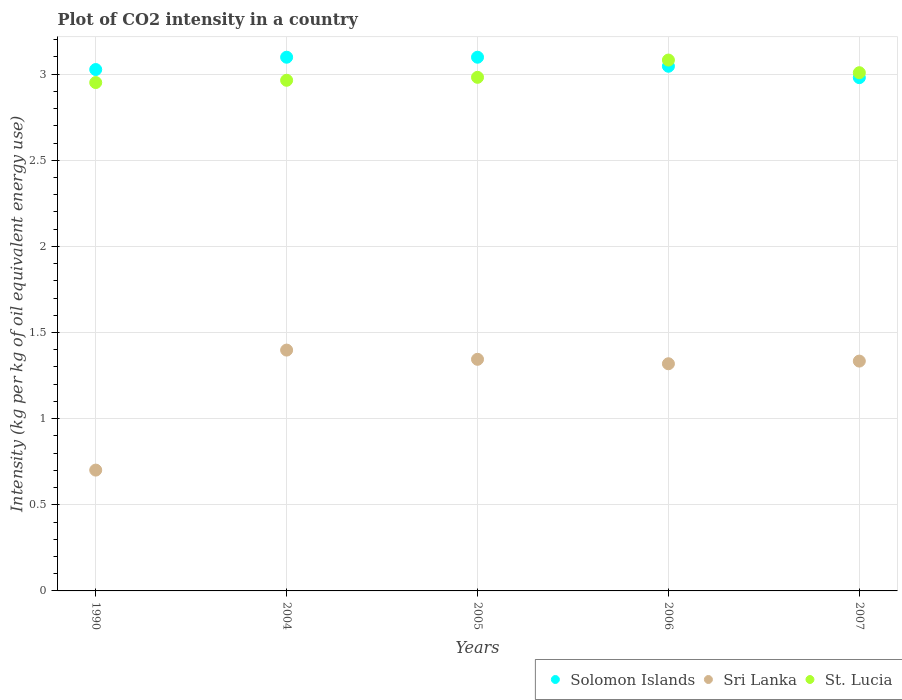What is the CO2 intensity in in Sri Lanka in 2004?
Your answer should be very brief. 1.4. Across all years, what is the maximum CO2 intensity in in St. Lucia?
Your answer should be compact. 3.08. Across all years, what is the minimum CO2 intensity in in St. Lucia?
Your answer should be compact. 2.95. In which year was the CO2 intensity in in St. Lucia maximum?
Provide a succinct answer. 2006. What is the total CO2 intensity in in St. Lucia in the graph?
Offer a very short reply. 14.99. What is the difference between the CO2 intensity in in St. Lucia in 2006 and that in 2007?
Give a very brief answer. 0.07. What is the difference between the CO2 intensity in in Solomon Islands in 2004 and the CO2 intensity in in St. Lucia in 2007?
Offer a very short reply. 0.09. What is the average CO2 intensity in in St. Lucia per year?
Ensure brevity in your answer.  3. In the year 2007, what is the difference between the CO2 intensity in in Sri Lanka and CO2 intensity in in St. Lucia?
Give a very brief answer. -1.67. In how many years, is the CO2 intensity in in St. Lucia greater than 2.2 kg?
Make the answer very short. 5. What is the ratio of the CO2 intensity in in St. Lucia in 1990 to that in 2007?
Give a very brief answer. 0.98. Is the difference between the CO2 intensity in in Sri Lanka in 2004 and 2005 greater than the difference between the CO2 intensity in in St. Lucia in 2004 and 2005?
Your answer should be compact. Yes. What is the difference between the highest and the lowest CO2 intensity in in Sri Lanka?
Keep it short and to the point. 0.7. In how many years, is the CO2 intensity in in Sri Lanka greater than the average CO2 intensity in in Sri Lanka taken over all years?
Keep it short and to the point. 4. Is it the case that in every year, the sum of the CO2 intensity in in St. Lucia and CO2 intensity in in Solomon Islands  is greater than the CO2 intensity in in Sri Lanka?
Provide a succinct answer. Yes. Does the CO2 intensity in in Solomon Islands monotonically increase over the years?
Offer a very short reply. No. Is the CO2 intensity in in St. Lucia strictly less than the CO2 intensity in in Sri Lanka over the years?
Offer a very short reply. No. How are the legend labels stacked?
Make the answer very short. Horizontal. What is the title of the graph?
Ensure brevity in your answer.  Plot of CO2 intensity in a country. What is the label or title of the X-axis?
Offer a very short reply. Years. What is the label or title of the Y-axis?
Your answer should be compact. Intensity (kg per kg of oil equivalent energy use). What is the Intensity (kg per kg of oil equivalent energy use) of Solomon Islands in 1990?
Provide a short and direct response. 3.03. What is the Intensity (kg per kg of oil equivalent energy use) in Sri Lanka in 1990?
Your answer should be compact. 0.7. What is the Intensity (kg per kg of oil equivalent energy use) in St. Lucia in 1990?
Your answer should be compact. 2.95. What is the Intensity (kg per kg of oil equivalent energy use) of Solomon Islands in 2004?
Offer a very short reply. 3.1. What is the Intensity (kg per kg of oil equivalent energy use) of Sri Lanka in 2004?
Offer a very short reply. 1.4. What is the Intensity (kg per kg of oil equivalent energy use) of St. Lucia in 2004?
Your answer should be compact. 2.96. What is the Intensity (kg per kg of oil equivalent energy use) in Solomon Islands in 2005?
Your response must be concise. 3.1. What is the Intensity (kg per kg of oil equivalent energy use) of Sri Lanka in 2005?
Provide a succinct answer. 1.34. What is the Intensity (kg per kg of oil equivalent energy use) of St. Lucia in 2005?
Offer a terse response. 2.98. What is the Intensity (kg per kg of oil equivalent energy use) in Solomon Islands in 2006?
Keep it short and to the point. 3.05. What is the Intensity (kg per kg of oil equivalent energy use) in Sri Lanka in 2006?
Your response must be concise. 1.32. What is the Intensity (kg per kg of oil equivalent energy use) of St. Lucia in 2006?
Keep it short and to the point. 3.08. What is the Intensity (kg per kg of oil equivalent energy use) in Solomon Islands in 2007?
Give a very brief answer. 2.98. What is the Intensity (kg per kg of oil equivalent energy use) of Sri Lanka in 2007?
Your answer should be very brief. 1.33. What is the Intensity (kg per kg of oil equivalent energy use) in St. Lucia in 2007?
Offer a terse response. 3.01. Across all years, what is the maximum Intensity (kg per kg of oil equivalent energy use) in Solomon Islands?
Keep it short and to the point. 3.1. Across all years, what is the maximum Intensity (kg per kg of oil equivalent energy use) of Sri Lanka?
Provide a succinct answer. 1.4. Across all years, what is the maximum Intensity (kg per kg of oil equivalent energy use) of St. Lucia?
Offer a very short reply. 3.08. Across all years, what is the minimum Intensity (kg per kg of oil equivalent energy use) of Solomon Islands?
Give a very brief answer. 2.98. Across all years, what is the minimum Intensity (kg per kg of oil equivalent energy use) in Sri Lanka?
Offer a terse response. 0.7. Across all years, what is the minimum Intensity (kg per kg of oil equivalent energy use) of St. Lucia?
Your answer should be very brief. 2.95. What is the total Intensity (kg per kg of oil equivalent energy use) in Solomon Islands in the graph?
Offer a very short reply. 15.25. What is the total Intensity (kg per kg of oil equivalent energy use) in Sri Lanka in the graph?
Offer a very short reply. 6.1. What is the total Intensity (kg per kg of oil equivalent energy use) of St. Lucia in the graph?
Your answer should be very brief. 14.99. What is the difference between the Intensity (kg per kg of oil equivalent energy use) in Solomon Islands in 1990 and that in 2004?
Provide a short and direct response. -0.07. What is the difference between the Intensity (kg per kg of oil equivalent energy use) in Sri Lanka in 1990 and that in 2004?
Offer a terse response. -0.7. What is the difference between the Intensity (kg per kg of oil equivalent energy use) of St. Lucia in 1990 and that in 2004?
Offer a terse response. -0.01. What is the difference between the Intensity (kg per kg of oil equivalent energy use) in Solomon Islands in 1990 and that in 2005?
Your response must be concise. -0.07. What is the difference between the Intensity (kg per kg of oil equivalent energy use) of Sri Lanka in 1990 and that in 2005?
Offer a very short reply. -0.64. What is the difference between the Intensity (kg per kg of oil equivalent energy use) of St. Lucia in 1990 and that in 2005?
Your response must be concise. -0.03. What is the difference between the Intensity (kg per kg of oil equivalent energy use) of Solomon Islands in 1990 and that in 2006?
Your answer should be very brief. -0.02. What is the difference between the Intensity (kg per kg of oil equivalent energy use) of Sri Lanka in 1990 and that in 2006?
Offer a very short reply. -0.62. What is the difference between the Intensity (kg per kg of oil equivalent energy use) of St. Lucia in 1990 and that in 2006?
Offer a very short reply. -0.13. What is the difference between the Intensity (kg per kg of oil equivalent energy use) of Solomon Islands in 1990 and that in 2007?
Your answer should be very brief. 0.05. What is the difference between the Intensity (kg per kg of oil equivalent energy use) of Sri Lanka in 1990 and that in 2007?
Offer a very short reply. -0.63. What is the difference between the Intensity (kg per kg of oil equivalent energy use) in St. Lucia in 1990 and that in 2007?
Offer a very short reply. -0.06. What is the difference between the Intensity (kg per kg of oil equivalent energy use) of Solomon Islands in 2004 and that in 2005?
Ensure brevity in your answer.  0. What is the difference between the Intensity (kg per kg of oil equivalent energy use) of Sri Lanka in 2004 and that in 2005?
Ensure brevity in your answer.  0.05. What is the difference between the Intensity (kg per kg of oil equivalent energy use) in St. Lucia in 2004 and that in 2005?
Give a very brief answer. -0.02. What is the difference between the Intensity (kg per kg of oil equivalent energy use) in Solomon Islands in 2004 and that in 2006?
Provide a succinct answer. 0.05. What is the difference between the Intensity (kg per kg of oil equivalent energy use) in Sri Lanka in 2004 and that in 2006?
Keep it short and to the point. 0.08. What is the difference between the Intensity (kg per kg of oil equivalent energy use) of St. Lucia in 2004 and that in 2006?
Give a very brief answer. -0.12. What is the difference between the Intensity (kg per kg of oil equivalent energy use) in Solomon Islands in 2004 and that in 2007?
Your answer should be very brief. 0.12. What is the difference between the Intensity (kg per kg of oil equivalent energy use) in Sri Lanka in 2004 and that in 2007?
Offer a very short reply. 0.06. What is the difference between the Intensity (kg per kg of oil equivalent energy use) in St. Lucia in 2004 and that in 2007?
Offer a very short reply. -0.04. What is the difference between the Intensity (kg per kg of oil equivalent energy use) in Solomon Islands in 2005 and that in 2006?
Provide a succinct answer. 0.05. What is the difference between the Intensity (kg per kg of oil equivalent energy use) of Sri Lanka in 2005 and that in 2006?
Make the answer very short. 0.03. What is the difference between the Intensity (kg per kg of oil equivalent energy use) of St. Lucia in 2005 and that in 2006?
Give a very brief answer. -0.1. What is the difference between the Intensity (kg per kg of oil equivalent energy use) of Solomon Islands in 2005 and that in 2007?
Ensure brevity in your answer.  0.12. What is the difference between the Intensity (kg per kg of oil equivalent energy use) of Sri Lanka in 2005 and that in 2007?
Provide a succinct answer. 0.01. What is the difference between the Intensity (kg per kg of oil equivalent energy use) of St. Lucia in 2005 and that in 2007?
Your answer should be very brief. -0.03. What is the difference between the Intensity (kg per kg of oil equivalent energy use) in Solomon Islands in 2006 and that in 2007?
Offer a very short reply. 0.07. What is the difference between the Intensity (kg per kg of oil equivalent energy use) of Sri Lanka in 2006 and that in 2007?
Make the answer very short. -0.02. What is the difference between the Intensity (kg per kg of oil equivalent energy use) in St. Lucia in 2006 and that in 2007?
Provide a short and direct response. 0.07. What is the difference between the Intensity (kg per kg of oil equivalent energy use) in Solomon Islands in 1990 and the Intensity (kg per kg of oil equivalent energy use) in Sri Lanka in 2004?
Make the answer very short. 1.63. What is the difference between the Intensity (kg per kg of oil equivalent energy use) of Solomon Islands in 1990 and the Intensity (kg per kg of oil equivalent energy use) of St. Lucia in 2004?
Make the answer very short. 0.06. What is the difference between the Intensity (kg per kg of oil equivalent energy use) in Sri Lanka in 1990 and the Intensity (kg per kg of oil equivalent energy use) in St. Lucia in 2004?
Offer a terse response. -2.26. What is the difference between the Intensity (kg per kg of oil equivalent energy use) in Solomon Islands in 1990 and the Intensity (kg per kg of oil equivalent energy use) in Sri Lanka in 2005?
Offer a terse response. 1.68. What is the difference between the Intensity (kg per kg of oil equivalent energy use) of Solomon Islands in 1990 and the Intensity (kg per kg of oil equivalent energy use) of St. Lucia in 2005?
Ensure brevity in your answer.  0.05. What is the difference between the Intensity (kg per kg of oil equivalent energy use) of Sri Lanka in 1990 and the Intensity (kg per kg of oil equivalent energy use) of St. Lucia in 2005?
Ensure brevity in your answer.  -2.28. What is the difference between the Intensity (kg per kg of oil equivalent energy use) in Solomon Islands in 1990 and the Intensity (kg per kg of oil equivalent energy use) in Sri Lanka in 2006?
Your response must be concise. 1.71. What is the difference between the Intensity (kg per kg of oil equivalent energy use) in Solomon Islands in 1990 and the Intensity (kg per kg of oil equivalent energy use) in St. Lucia in 2006?
Give a very brief answer. -0.06. What is the difference between the Intensity (kg per kg of oil equivalent energy use) of Sri Lanka in 1990 and the Intensity (kg per kg of oil equivalent energy use) of St. Lucia in 2006?
Offer a very short reply. -2.38. What is the difference between the Intensity (kg per kg of oil equivalent energy use) in Solomon Islands in 1990 and the Intensity (kg per kg of oil equivalent energy use) in Sri Lanka in 2007?
Your answer should be very brief. 1.69. What is the difference between the Intensity (kg per kg of oil equivalent energy use) of Solomon Islands in 1990 and the Intensity (kg per kg of oil equivalent energy use) of St. Lucia in 2007?
Your answer should be compact. 0.02. What is the difference between the Intensity (kg per kg of oil equivalent energy use) in Sri Lanka in 1990 and the Intensity (kg per kg of oil equivalent energy use) in St. Lucia in 2007?
Offer a terse response. -2.31. What is the difference between the Intensity (kg per kg of oil equivalent energy use) of Solomon Islands in 2004 and the Intensity (kg per kg of oil equivalent energy use) of Sri Lanka in 2005?
Make the answer very short. 1.75. What is the difference between the Intensity (kg per kg of oil equivalent energy use) of Solomon Islands in 2004 and the Intensity (kg per kg of oil equivalent energy use) of St. Lucia in 2005?
Your answer should be compact. 0.12. What is the difference between the Intensity (kg per kg of oil equivalent energy use) in Sri Lanka in 2004 and the Intensity (kg per kg of oil equivalent energy use) in St. Lucia in 2005?
Your answer should be compact. -1.58. What is the difference between the Intensity (kg per kg of oil equivalent energy use) of Solomon Islands in 2004 and the Intensity (kg per kg of oil equivalent energy use) of Sri Lanka in 2006?
Ensure brevity in your answer.  1.78. What is the difference between the Intensity (kg per kg of oil equivalent energy use) in Solomon Islands in 2004 and the Intensity (kg per kg of oil equivalent energy use) in St. Lucia in 2006?
Ensure brevity in your answer.  0.02. What is the difference between the Intensity (kg per kg of oil equivalent energy use) in Sri Lanka in 2004 and the Intensity (kg per kg of oil equivalent energy use) in St. Lucia in 2006?
Keep it short and to the point. -1.68. What is the difference between the Intensity (kg per kg of oil equivalent energy use) of Solomon Islands in 2004 and the Intensity (kg per kg of oil equivalent energy use) of Sri Lanka in 2007?
Provide a succinct answer. 1.76. What is the difference between the Intensity (kg per kg of oil equivalent energy use) in Solomon Islands in 2004 and the Intensity (kg per kg of oil equivalent energy use) in St. Lucia in 2007?
Provide a short and direct response. 0.09. What is the difference between the Intensity (kg per kg of oil equivalent energy use) in Sri Lanka in 2004 and the Intensity (kg per kg of oil equivalent energy use) in St. Lucia in 2007?
Your answer should be compact. -1.61. What is the difference between the Intensity (kg per kg of oil equivalent energy use) of Solomon Islands in 2005 and the Intensity (kg per kg of oil equivalent energy use) of Sri Lanka in 2006?
Give a very brief answer. 1.78. What is the difference between the Intensity (kg per kg of oil equivalent energy use) of Solomon Islands in 2005 and the Intensity (kg per kg of oil equivalent energy use) of St. Lucia in 2006?
Make the answer very short. 0.02. What is the difference between the Intensity (kg per kg of oil equivalent energy use) of Sri Lanka in 2005 and the Intensity (kg per kg of oil equivalent energy use) of St. Lucia in 2006?
Give a very brief answer. -1.74. What is the difference between the Intensity (kg per kg of oil equivalent energy use) of Solomon Islands in 2005 and the Intensity (kg per kg of oil equivalent energy use) of Sri Lanka in 2007?
Offer a terse response. 1.76. What is the difference between the Intensity (kg per kg of oil equivalent energy use) in Solomon Islands in 2005 and the Intensity (kg per kg of oil equivalent energy use) in St. Lucia in 2007?
Your response must be concise. 0.09. What is the difference between the Intensity (kg per kg of oil equivalent energy use) in Sri Lanka in 2005 and the Intensity (kg per kg of oil equivalent energy use) in St. Lucia in 2007?
Provide a succinct answer. -1.66. What is the difference between the Intensity (kg per kg of oil equivalent energy use) of Solomon Islands in 2006 and the Intensity (kg per kg of oil equivalent energy use) of Sri Lanka in 2007?
Offer a terse response. 1.71. What is the difference between the Intensity (kg per kg of oil equivalent energy use) in Solomon Islands in 2006 and the Intensity (kg per kg of oil equivalent energy use) in St. Lucia in 2007?
Your answer should be very brief. 0.04. What is the difference between the Intensity (kg per kg of oil equivalent energy use) of Sri Lanka in 2006 and the Intensity (kg per kg of oil equivalent energy use) of St. Lucia in 2007?
Offer a very short reply. -1.69. What is the average Intensity (kg per kg of oil equivalent energy use) of Solomon Islands per year?
Offer a very short reply. 3.05. What is the average Intensity (kg per kg of oil equivalent energy use) in Sri Lanka per year?
Make the answer very short. 1.22. What is the average Intensity (kg per kg of oil equivalent energy use) in St. Lucia per year?
Provide a succinct answer. 3. In the year 1990, what is the difference between the Intensity (kg per kg of oil equivalent energy use) in Solomon Islands and Intensity (kg per kg of oil equivalent energy use) in Sri Lanka?
Your answer should be very brief. 2.33. In the year 1990, what is the difference between the Intensity (kg per kg of oil equivalent energy use) of Solomon Islands and Intensity (kg per kg of oil equivalent energy use) of St. Lucia?
Provide a short and direct response. 0.08. In the year 1990, what is the difference between the Intensity (kg per kg of oil equivalent energy use) of Sri Lanka and Intensity (kg per kg of oil equivalent energy use) of St. Lucia?
Provide a short and direct response. -2.25. In the year 2004, what is the difference between the Intensity (kg per kg of oil equivalent energy use) in Solomon Islands and Intensity (kg per kg of oil equivalent energy use) in Sri Lanka?
Your answer should be compact. 1.7. In the year 2004, what is the difference between the Intensity (kg per kg of oil equivalent energy use) of Solomon Islands and Intensity (kg per kg of oil equivalent energy use) of St. Lucia?
Your answer should be compact. 0.13. In the year 2004, what is the difference between the Intensity (kg per kg of oil equivalent energy use) in Sri Lanka and Intensity (kg per kg of oil equivalent energy use) in St. Lucia?
Offer a terse response. -1.57. In the year 2005, what is the difference between the Intensity (kg per kg of oil equivalent energy use) in Solomon Islands and Intensity (kg per kg of oil equivalent energy use) in Sri Lanka?
Offer a very short reply. 1.75. In the year 2005, what is the difference between the Intensity (kg per kg of oil equivalent energy use) in Solomon Islands and Intensity (kg per kg of oil equivalent energy use) in St. Lucia?
Give a very brief answer. 0.12. In the year 2005, what is the difference between the Intensity (kg per kg of oil equivalent energy use) of Sri Lanka and Intensity (kg per kg of oil equivalent energy use) of St. Lucia?
Make the answer very short. -1.64. In the year 2006, what is the difference between the Intensity (kg per kg of oil equivalent energy use) of Solomon Islands and Intensity (kg per kg of oil equivalent energy use) of Sri Lanka?
Keep it short and to the point. 1.73. In the year 2006, what is the difference between the Intensity (kg per kg of oil equivalent energy use) in Solomon Islands and Intensity (kg per kg of oil equivalent energy use) in St. Lucia?
Provide a succinct answer. -0.04. In the year 2006, what is the difference between the Intensity (kg per kg of oil equivalent energy use) in Sri Lanka and Intensity (kg per kg of oil equivalent energy use) in St. Lucia?
Your answer should be compact. -1.76. In the year 2007, what is the difference between the Intensity (kg per kg of oil equivalent energy use) in Solomon Islands and Intensity (kg per kg of oil equivalent energy use) in Sri Lanka?
Make the answer very short. 1.65. In the year 2007, what is the difference between the Intensity (kg per kg of oil equivalent energy use) of Solomon Islands and Intensity (kg per kg of oil equivalent energy use) of St. Lucia?
Offer a terse response. -0.03. In the year 2007, what is the difference between the Intensity (kg per kg of oil equivalent energy use) in Sri Lanka and Intensity (kg per kg of oil equivalent energy use) in St. Lucia?
Give a very brief answer. -1.67. What is the ratio of the Intensity (kg per kg of oil equivalent energy use) in Solomon Islands in 1990 to that in 2004?
Ensure brevity in your answer.  0.98. What is the ratio of the Intensity (kg per kg of oil equivalent energy use) of Sri Lanka in 1990 to that in 2004?
Your answer should be very brief. 0.5. What is the ratio of the Intensity (kg per kg of oil equivalent energy use) in Solomon Islands in 1990 to that in 2005?
Ensure brevity in your answer.  0.98. What is the ratio of the Intensity (kg per kg of oil equivalent energy use) in Sri Lanka in 1990 to that in 2005?
Your answer should be compact. 0.52. What is the ratio of the Intensity (kg per kg of oil equivalent energy use) of Solomon Islands in 1990 to that in 2006?
Your answer should be very brief. 0.99. What is the ratio of the Intensity (kg per kg of oil equivalent energy use) of Sri Lanka in 1990 to that in 2006?
Provide a succinct answer. 0.53. What is the ratio of the Intensity (kg per kg of oil equivalent energy use) in St. Lucia in 1990 to that in 2006?
Offer a very short reply. 0.96. What is the ratio of the Intensity (kg per kg of oil equivalent energy use) of Solomon Islands in 1990 to that in 2007?
Your response must be concise. 1.02. What is the ratio of the Intensity (kg per kg of oil equivalent energy use) in Sri Lanka in 1990 to that in 2007?
Your answer should be compact. 0.53. What is the ratio of the Intensity (kg per kg of oil equivalent energy use) of Sri Lanka in 2004 to that in 2005?
Provide a short and direct response. 1.04. What is the ratio of the Intensity (kg per kg of oil equivalent energy use) in Solomon Islands in 2004 to that in 2006?
Ensure brevity in your answer.  1.02. What is the ratio of the Intensity (kg per kg of oil equivalent energy use) of Sri Lanka in 2004 to that in 2006?
Your response must be concise. 1.06. What is the ratio of the Intensity (kg per kg of oil equivalent energy use) of St. Lucia in 2004 to that in 2006?
Offer a very short reply. 0.96. What is the ratio of the Intensity (kg per kg of oil equivalent energy use) of Solomon Islands in 2004 to that in 2007?
Offer a very short reply. 1.04. What is the ratio of the Intensity (kg per kg of oil equivalent energy use) in Sri Lanka in 2004 to that in 2007?
Keep it short and to the point. 1.05. What is the ratio of the Intensity (kg per kg of oil equivalent energy use) of St. Lucia in 2004 to that in 2007?
Provide a short and direct response. 0.99. What is the ratio of the Intensity (kg per kg of oil equivalent energy use) of Solomon Islands in 2005 to that in 2006?
Your answer should be compact. 1.02. What is the ratio of the Intensity (kg per kg of oil equivalent energy use) in Sri Lanka in 2005 to that in 2006?
Make the answer very short. 1.02. What is the ratio of the Intensity (kg per kg of oil equivalent energy use) of St. Lucia in 2005 to that in 2006?
Make the answer very short. 0.97. What is the ratio of the Intensity (kg per kg of oil equivalent energy use) in Solomon Islands in 2005 to that in 2007?
Keep it short and to the point. 1.04. What is the ratio of the Intensity (kg per kg of oil equivalent energy use) in Sri Lanka in 2005 to that in 2007?
Ensure brevity in your answer.  1.01. What is the ratio of the Intensity (kg per kg of oil equivalent energy use) in St. Lucia in 2005 to that in 2007?
Ensure brevity in your answer.  0.99. What is the ratio of the Intensity (kg per kg of oil equivalent energy use) in Solomon Islands in 2006 to that in 2007?
Your answer should be compact. 1.02. What is the ratio of the Intensity (kg per kg of oil equivalent energy use) in Sri Lanka in 2006 to that in 2007?
Your answer should be very brief. 0.99. What is the ratio of the Intensity (kg per kg of oil equivalent energy use) of St. Lucia in 2006 to that in 2007?
Keep it short and to the point. 1.02. What is the difference between the highest and the second highest Intensity (kg per kg of oil equivalent energy use) of Sri Lanka?
Your answer should be very brief. 0.05. What is the difference between the highest and the second highest Intensity (kg per kg of oil equivalent energy use) in St. Lucia?
Make the answer very short. 0.07. What is the difference between the highest and the lowest Intensity (kg per kg of oil equivalent energy use) in Solomon Islands?
Offer a very short reply. 0.12. What is the difference between the highest and the lowest Intensity (kg per kg of oil equivalent energy use) in Sri Lanka?
Make the answer very short. 0.7. What is the difference between the highest and the lowest Intensity (kg per kg of oil equivalent energy use) in St. Lucia?
Offer a terse response. 0.13. 